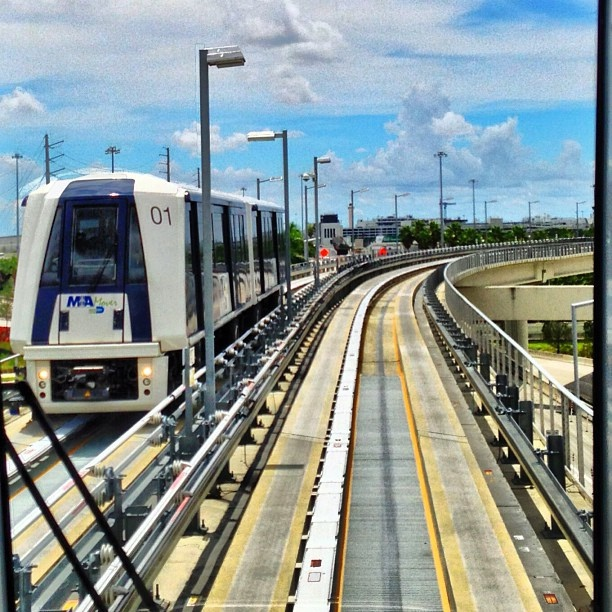Describe the objects in this image and their specific colors. I can see a train in lightgray, black, darkgray, and gray tones in this image. 